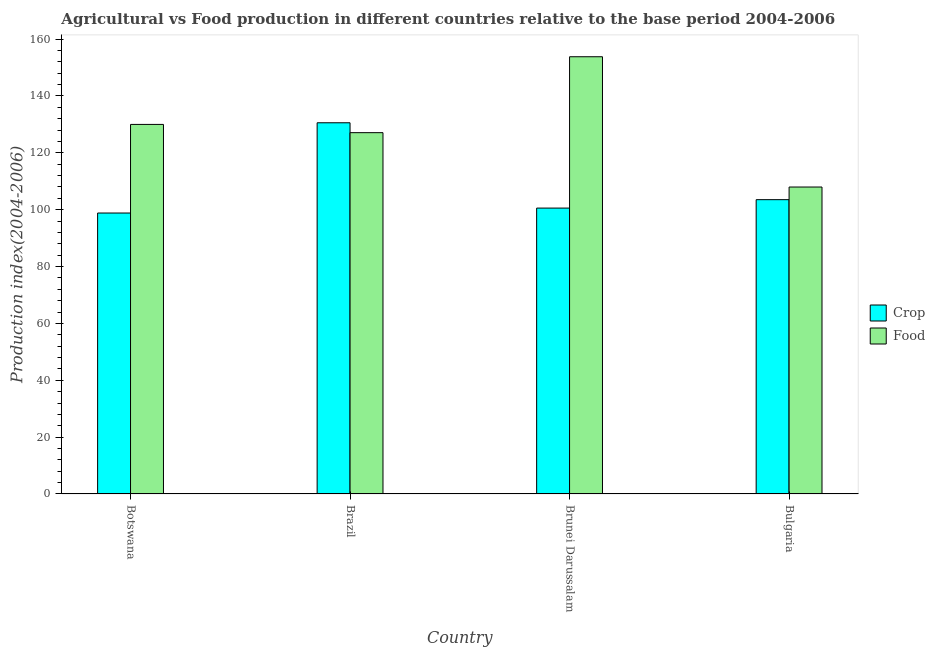How many different coloured bars are there?
Your answer should be very brief. 2. How many groups of bars are there?
Make the answer very short. 4. Are the number of bars per tick equal to the number of legend labels?
Your answer should be compact. Yes. Are the number of bars on each tick of the X-axis equal?
Your answer should be very brief. Yes. What is the label of the 1st group of bars from the left?
Ensure brevity in your answer.  Botswana. In how many cases, is the number of bars for a given country not equal to the number of legend labels?
Your answer should be very brief. 0. What is the food production index in Brazil?
Provide a short and direct response. 127.1. Across all countries, what is the maximum crop production index?
Your answer should be very brief. 130.58. Across all countries, what is the minimum food production index?
Offer a terse response. 107.98. In which country was the food production index maximum?
Offer a terse response. Brunei Darussalam. In which country was the crop production index minimum?
Provide a short and direct response. Botswana. What is the total crop production index in the graph?
Your answer should be very brief. 433.51. What is the difference between the crop production index in Botswana and that in Brazil?
Your response must be concise. -31.75. What is the difference between the food production index in Bulgaria and the crop production index in Brazil?
Your answer should be compact. -22.6. What is the average crop production index per country?
Your response must be concise. 108.38. What is the difference between the crop production index and food production index in Botswana?
Ensure brevity in your answer.  -31.17. What is the ratio of the crop production index in Botswana to that in Brazil?
Keep it short and to the point. 0.76. Is the crop production index in Botswana less than that in Bulgaria?
Make the answer very short. Yes. What is the difference between the highest and the second highest food production index?
Ensure brevity in your answer.  23.81. What is the difference between the highest and the lowest crop production index?
Provide a succinct answer. 31.75. In how many countries, is the food production index greater than the average food production index taken over all countries?
Offer a terse response. 2. What does the 2nd bar from the left in Brunei Darussalam represents?
Keep it short and to the point. Food. What does the 2nd bar from the right in Botswana represents?
Offer a very short reply. Crop. How many bars are there?
Your answer should be very brief. 8. How many countries are there in the graph?
Offer a very short reply. 4. What is the difference between two consecutive major ticks on the Y-axis?
Your answer should be compact. 20. Are the values on the major ticks of Y-axis written in scientific E-notation?
Ensure brevity in your answer.  No. Does the graph contain grids?
Your answer should be compact. No. How many legend labels are there?
Keep it short and to the point. 2. How are the legend labels stacked?
Provide a short and direct response. Vertical. What is the title of the graph?
Offer a terse response. Agricultural vs Food production in different countries relative to the base period 2004-2006. Does "DAC donors" appear as one of the legend labels in the graph?
Ensure brevity in your answer.  No. What is the label or title of the Y-axis?
Provide a short and direct response. Production index(2004-2006). What is the Production index(2004-2006) of Crop in Botswana?
Make the answer very short. 98.83. What is the Production index(2004-2006) of Food in Botswana?
Make the answer very short. 130. What is the Production index(2004-2006) of Crop in Brazil?
Offer a terse response. 130.58. What is the Production index(2004-2006) of Food in Brazil?
Make the answer very short. 127.1. What is the Production index(2004-2006) of Crop in Brunei Darussalam?
Keep it short and to the point. 100.57. What is the Production index(2004-2006) of Food in Brunei Darussalam?
Provide a short and direct response. 153.81. What is the Production index(2004-2006) of Crop in Bulgaria?
Give a very brief answer. 103.53. What is the Production index(2004-2006) in Food in Bulgaria?
Offer a terse response. 107.98. Across all countries, what is the maximum Production index(2004-2006) of Crop?
Your answer should be compact. 130.58. Across all countries, what is the maximum Production index(2004-2006) in Food?
Provide a short and direct response. 153.81. Across all countries, what is the minimum Production index(2004-2006) of Crop?
Your answer should be compact. 98.83. Across all countries, what is the minimum Production index(2004-2006) in Food?
Give a very brief answer. 107.98. What is the total Production index(2004-2006) of Crop in the graph?
Offer a very short reply. 433.51. What is the total Production index(2004-2006) in Food in the graph?
Provide a short and direct response. 518.89. What is the difference between the Production index(2004-2006) of Crop in Botswana and that in Brazil?
Ensure brevity in your answer.  -31.75. What is the difference between the Production index(2004-2006) in Food in Botswana and that in Brazil?
Make the answer very short. 2.9. What is the difference between the Production index(2004-2006) in Crop in Botswana and that in Brunei Darussalam?
Keep it short and to the point. -1.74. What is the difference between the Production index(2004-2006) in Food in Botswana and that in Brunei Darussalam?
Make the answer very short. -23.81. What is the difference between the Production index(2004-2006) of Food in Botswana and that in Bulgaria?
Make the answer very short. 22.02. What is the difference between the Production index(2004-2006) of Crop in Brazil and that in Brunei Darussalam?
Your response must be concise. 30.01. What is the difference between the Production index(2004-2006) in Food in Brazil and that in Brunei Darussalam?
Keep it short and to the point. -26.71. What is the difference between the Production index(2004-2006) in Crop in Brazil and that in Bulgaria?
Keep it short and to the point. 27.05. What is the difference between the Production index(2004-2006) of Food in Brazil and that in Bulgaria?
Your response must be concise. 19.12. What is the difference between the Production index(2004-2006) in Crop in Brunei Darussalam and that in Bulgaria?
Your answer should be very brief. -2.96. What is the difference between the Production index(2004-2006) in Food in Brunei Darussalam and that in Bulgaria?
Your answer should be very brief. 45.83. What is the difference between the Production index(2004-2006) in Crop in Botswana and the Production index(2004-2006) in Food in Brazil?
Your answer should be very brief. -28.27. What is the difference between the Production index(2004-2006) of Crop in Botswana and the Production index(2004-2006) of Food in Brunei Darussalam?
Provide a short and direct response. -54.98. What is the difference between the Production index(2004-2006) of Crop in Botswana and the Production index(2004-2006) of Food in Bulgaria?
Offer a very short reply. -9.15. What is the difference between the Production index(2004-2006) of Crop in Brazil and the Production index(2004-2006) of Food in Brunei Darussalam?
Make the answer very short. -23.23. What is the difference between the Production index(2004-2006) of Crop in Brazil and the Production index(2004-2006) of Food in Bulgaria?
Your response must be concise. 22.6. What is the difference between the Production index(2004-2006) in Crop in Brunei Darussalam and the Production index(2004-2006) in Food in Bulgaria?
Offer a very short reply. -7.41. What is the average Production index(2004-2006) of Crop per country?
Give a very brief answer. 108.38. What is the average Production index(2004-2006) in Food per country?
Your response must be concise. 129.72. What is the difference between the Production index(2004-2006) in Crop and Production index(2004-2006) in Food in Botswana?
Your answer should be very brief. -31.17. What is the difference between the Production index(2004-2006) in Crop and Production index(2004-2006) in Food in Brazil?
Your response must be concise. 3.48. What is the difference between the Production index(2004-2006) in Crop and Production index(2004-2006) in Food in Brunei Darussalam?
Ensure brevity in your answer.  -53.24. What is the difference between the Production index(2004-2006) in Crop and Production index(2004-2006) in Food in Bulgaria?
Your answer should be compact. -4.45. What is the ratio of the Production index(2004-2006) of Crop in Botswana to that in Brazil?
Make the answer very short. 0.76. What is the ratio of the Production index(2004-2006) in Food in Botswana to that in Brazil?
Offer a terse response. 1.02. What is the ratio of the Production index(2004-2006) of Crop in Botswana to that in Brunei Darussalam?
Provide a short and direct response. 0.98. What is the ratio of the Production index(2004-2006) in Food in Botswana to that in Brunei Darussalam?
Ensure brevity in your answer.  0.85. What is the ratio of the Production index(2004-2006) in Crop in Botswana to that in Bulgaria?
Provide a short and direct response. 0.95. What is the ratio of the Production index(2004-2006) of Food in Botswana to that in Bulgaria?
Your response must be concise. 1.2. What is the ratio of the Production index(2004-2006) in Crop in Brazil to that in Brunei Darussalam?
Your answer should be compact. 1.3. What is the ratio of the Production index(2004-2006) in Food in Brazil to that in Brunei Darussalam?
Offer a very short reply. 0.83. What is the ratio of the Production index(2004-2006) of Crop in Brazil to that in Bulgaria?
Your response must be concise. 1.26. What is the ratio of the Production index(2004-2006) in Food in Brazil to that in Bulgaria?
Offer a terse response. 1.18. What is the ratio of the Production index(2004-2006) in Crop in Brunei Darussalam to that in Bulgaria?
Offer a terse response. 0.97. What is the ratio of the Production index(2004-2006) in Food in Brunei Darussalam to that in Bulgaria?
Offer a very short reply. 1.42. What is the difference between the highest and the second highest Production index(2004-2006) of Crop?
Ensure brevity in your answer.  27.05. What is the difference between the highest and the second highest Production index(2004-2006) in Food?
Provide a succinct answer. 23.81. What is the difference between the highest and the lowest Production index(2004-2006) in Crop?
Give a very brief answer. 31.75. What is the difference between the highest and the lowest Production index(2004-2006) in Food?
Offer a very short reply. 45.83. 